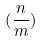<formula> <loc_0><loc_0><loc_500><loc_500>( \frac { n } { m } )</formula> 